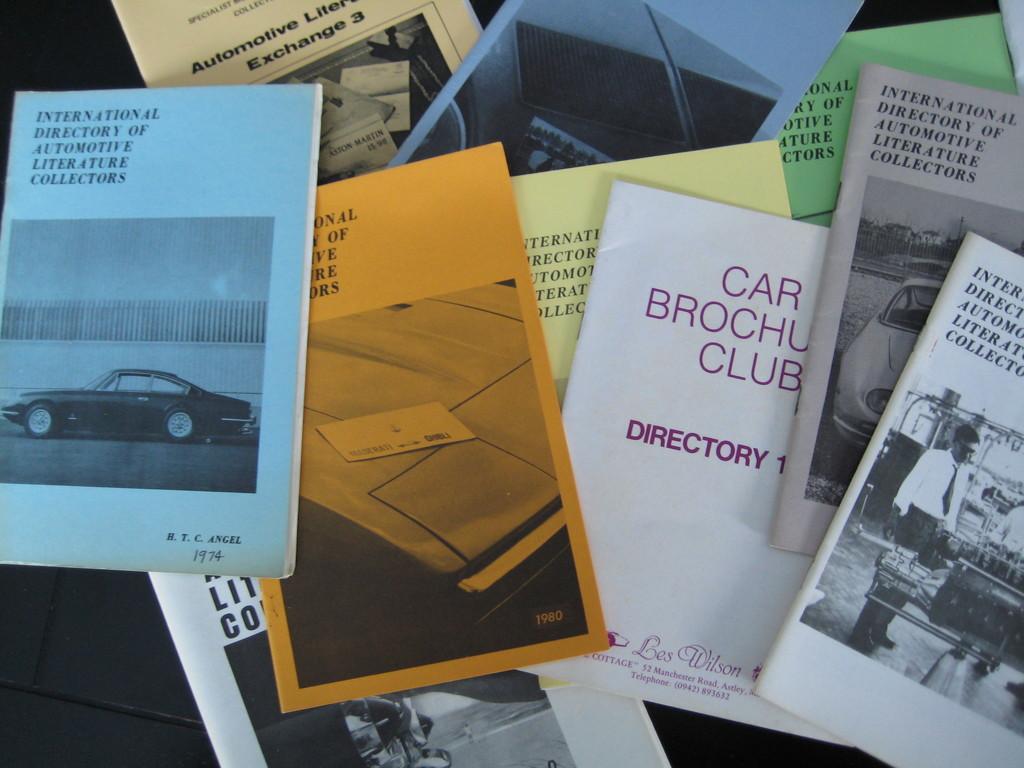What does it say in purple text on the white book?
Offer a very short reply. Car brochure club directory. 